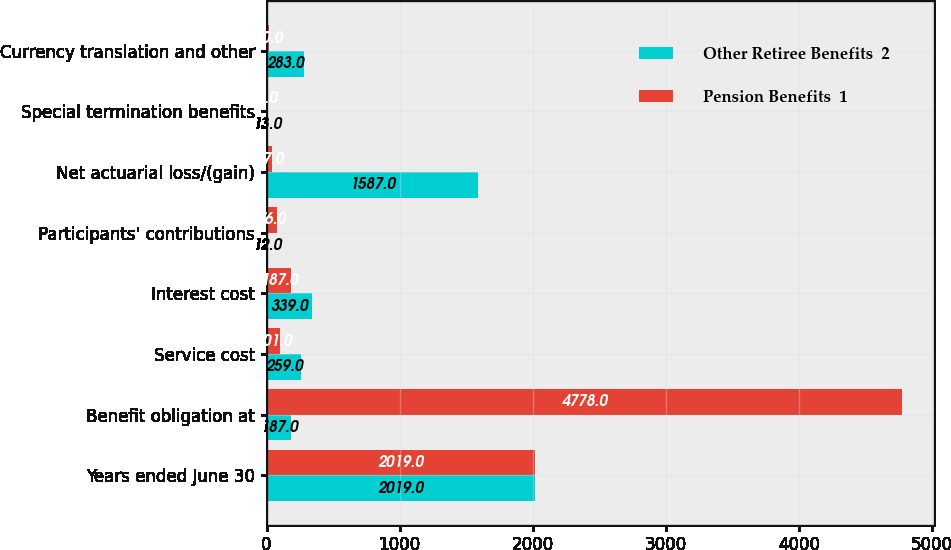<chart> <loc_0><loc_0><loc_500><loc_500><stacked_bar_chart><ecel><fcel>Years ended June 30<fcel>Benefit obligation at<fcel>Service cost<fcel>Interest cost<fcel>Participants' contributions<fcel>Net actuarial loss/(gain)<fcel>Special termination benefits<fcel>Currency translation and other<nl><fcel>Other Retiree Benefits  2<fcel>2019<fcel>187<fcel>259<fcel>339<fcel>12<fcel>1587<fcel>13<fcel>283<nl><fcel>Pension Benefits  1<fcel>2019<fcel>4778<fcel>101<fcel>187<fcel>76<fcel>37<fcel>8<fcel>20<nl></chart> 